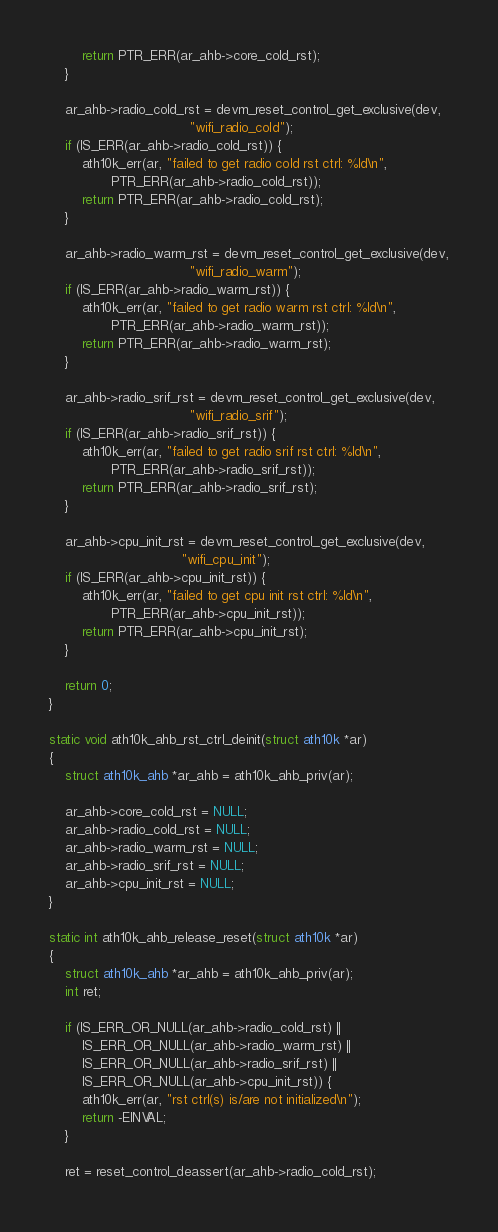Convert code to text. <code><loc_0><loc_0><loc_500><loc_500><_C_>		return PTR_ERR(ar_ahb->core_cold_rst);
	}

	ar_ahb->radio_cold_rst = devm_reset_control_get_exclusive(dev,
								  "wifi_radio_cold");
	if (IS_ERR(ar_ahb->radio_cold_rst)) {
		ath10k_err(ar, "failed to get radio cold rst ctrl: %ld\n",
			   PTR_ERR(ar_ahb->radio_cold_rst));
		return PTR_ERR(ar_ahb->radio_cold_rst);
	}

	ar_ahb->radio_warm_rst = devm_reset_control_get_exclusive(dev,
								  "wifi_radio_warm");
	if (IS_ERR(ar_ahb->radio_warm_rst)) {
		ath10k_err(ar, "failed to get radio warm rst ctrl: %ld\n",
			   PTR_ERR(ar_ahb->radio_warm_rst));
		return PTR_ERR(ar_ahb->radio_warm_rst);
	}

	ar_ahb->radio_srif_rst = devm_reset_control_get_exclusive(dev,
								  "wifi_radio_srif");
	if (IS_ERR(ar_ahb->radio_srif_rst)) {
		ath10k_err(ar, "failed to get radio srif rst ctrl: %ld\n",
			   PTR_ERR(ar_ahb->radio_srif_rst));
		return PTR_ERR(ar_ahb->radio_srif_rst);
	}

	ar_ahb->cpu_init_rst = devm_reset_control_get_exclusive(dev,
								"wifi_cpu_init");
	if (IS_ERR(ar_ahb->cpu_init_rst)) {
		ath10k_err(ar, "failed to get cpu init rst ctrl: %ld\n",
			   PTR_ERR(ar_ahb->cpu_init_rst));
		return PTR_ERR(ar_ahb->cpu_init_rst);
	}

	return 0;
}

static void ath10k_ahb_rst_ctrl_deinit(struct ath10k *ar)
{
	struct ath10k_ahb *ar_ahb = ath10k_ahb_priv(ar);

	ar_ahb->core_cold_rst = NULL;
	ar_ahb->radio_cold_rst = NULL;
	ar_ahb->radio_warm_rst = NULL;
	ar_ahb->radio_srif_rst = NULL;
	ar_ahb->cpu_init_rst = NULL;
}

static int ath10k_ahb_release_reset(struct ath10k *ar)
{
	struct ath10k_ahb *ar_ahb = ath10k_ahb_priv(ar);
	int ret;

	if (IS_ERR_OR_NULL(ar_ahb->radio_cold_rst) ||
	    IS_ERR_OR_NULL(ar_ahb->radio_warm_rst) ||
	    IS_ERR_OR_NULL(ar_ahb->radio_srif_rst) ||
	    IS_ERR_OR_NULL(ar_ahb->cpu_init_rst)) {
		ath10k_err(ar, "rst ctrl(s) is/are not initialized\n");
		return -EINVAL;
	}

	ret = reset_control_deassert(ar_ahb->radio_cold_rst);</code> 